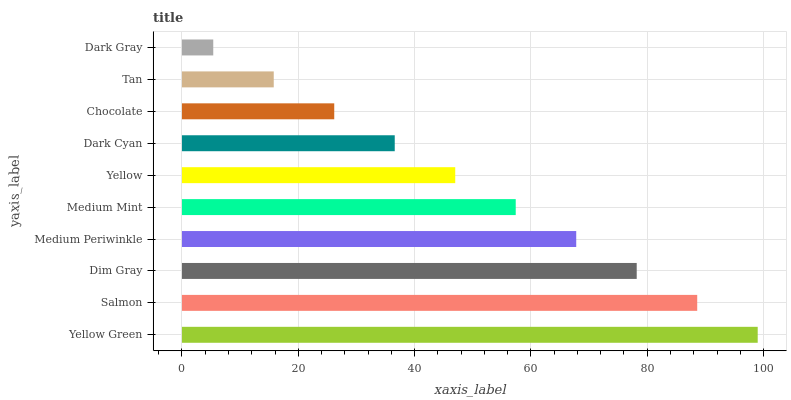Is Dark Gray the minimum?
Answer yes or no. Yes. Is Yellow Green the maximum?
Answer yes or no. Yes. Is Salmon the minimum?
Answer yes or no. No. Is Salmon the maximum?
Answer yes or no. No. Is Yellow Green greater than Salmon?
Answer yes or no. Yes. Is Salmon less than Yellow Green?
Answer yes or no. Yes. Is Salmon greater than Yellow Green?
Answer yes or no. No. Is Yellow Green less than Salmon?
Answer yes or no. No. Is Medium Mint the high median?
Answer yes or no. Yes. Is Yellow the low median?
Answer yes or no. Yes. Is Dim Gray the high median?
Answer yes or no. No. Is Dark Gray the low median?
Answer yes or no. No. 